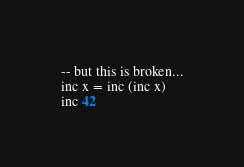<code> <loc_0><loc_0><loc_500><loc_500><_SML_>
-- but this is broken...
inc x = inc (inc x)
inc 42
</code> 